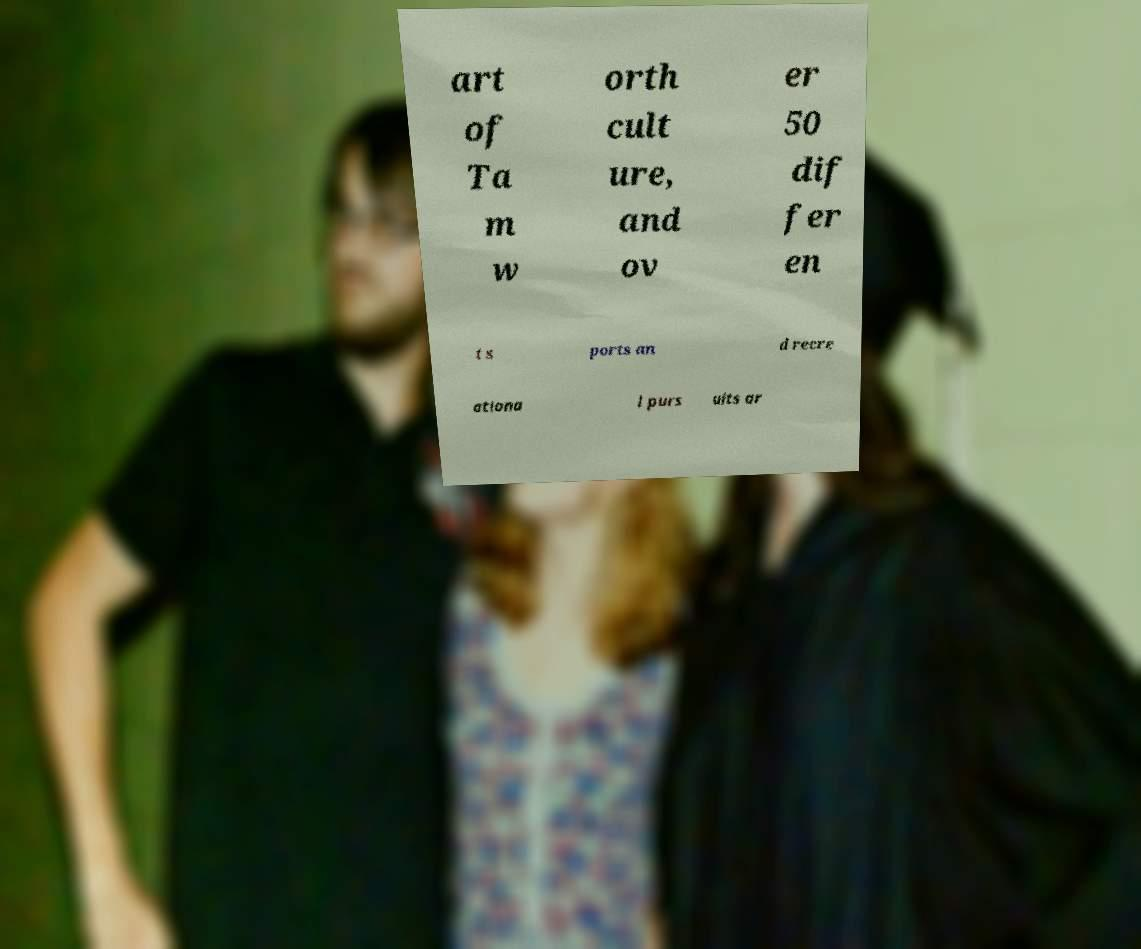For documentation purposes, I need the text within this image transcribed. Could you provide that? art of Ta m w orth cult ure, and ov er 50 dif fer en t s ports an d recre ationa l purs uits ar 